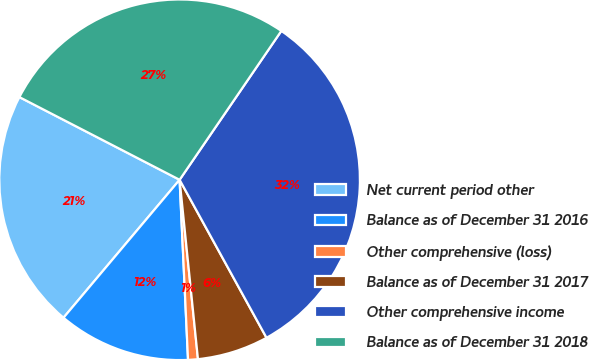<chart> <loc_0><loc_0><loc_500><loc_500><pie_chart><fcel>Net current period other<fcel>Balance as of December 31 2016<fcel>Other comprehensive (loss)<fcel>Balance as of December 31 2017<fcel>Other comprehensive income<fcel>Balance as of December 31 2018<nl><fcel>21.45%<fcel>11.88%<fcel>0.88%<fcel>6.38%<fcel>32.46%<fcel>26.96%<nl></chart> 